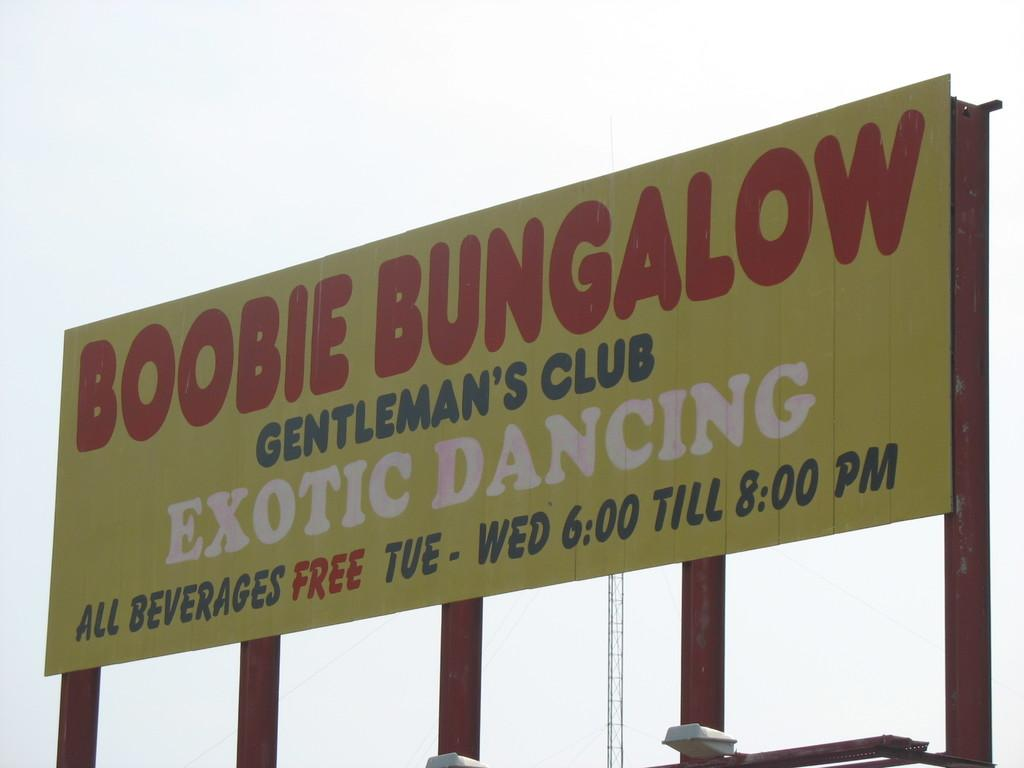<image>
Offer a succinct explanation of the picture presented. Yellow billboard with red words that say Boobie Bungalow. 